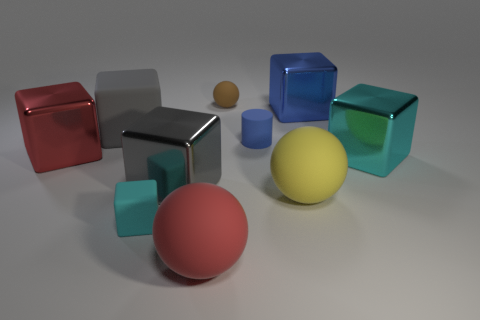What number of cyan objects are either matte cylinders or small rubber blocks?
Give a very brief answer. 1. The matte cylinder has what color?
Ensure brevity in your answer.  Blue. Is the size of the brown matte thing the same as the cyan matte thing?
Offer a very short reply. Yes. Is there any other thing that is the same shape as the blue matte thing?
Your response must be concise. No. Does the large red ball have the same material as the cyan thing to the right of the small sphere?
Offer a very short reply. No. Does the shiny block behind the gray rubber block have the same color as the cylinder?
Provide a succinct answer. Yes. How many metallic cubes are in front of the tiny cylinder and behind the large gray metal thing?
Provide a succinct answer. 2. How many other things are there of the same material as the small cube?
Your answer should be very brief. 5. Is the gray block that is in front of the small blue object made of the same material as the big red sphere?
Your answer should be compact. No. What is the size of the block on the right side of the metallic object that is behind the big red cube on the left side of the blue rubber cylinder?
Your answer should be compact. Large. 